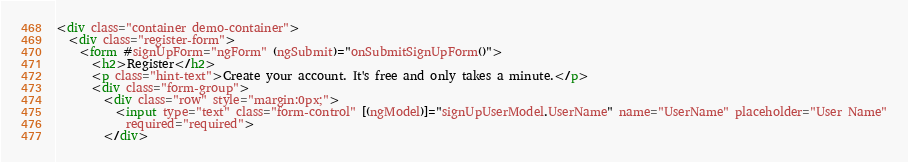<code> <loc_0><loc_0><loc_500><loc_500><_HTML_><div class="container demo-container">
  <div class="register-form">
    <form #signUpForm="ngForm" (ngSubmit)="onSubmitSignUpForm()">
      <h2>Register</h2>
      <p class="hint-text">Create your account. It's free and only takes a minute.</p>
      <div class="form-group">
        <div class="row" style="margin:0px;">
          <input type="text" class="form-control" [(ngModel)]="signUpUserModel.UserName" name="UserName" placeholder="User Name"
            required="required">
        </div></code> 